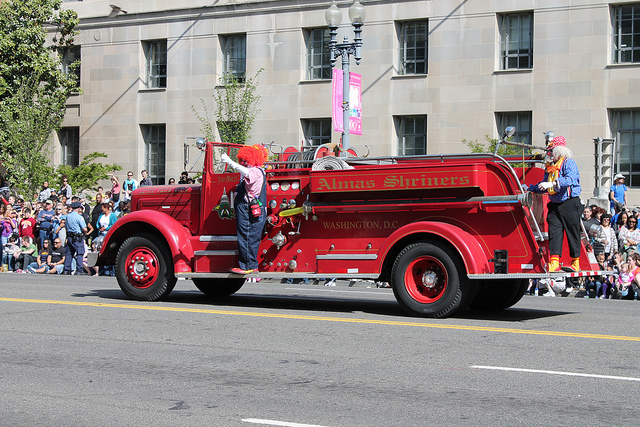<image>What is written on top of the truck? I don't know exactly what is written on top of the truck. It might be 'aluris shriners', 'almas shriners', 'shriners', or 'alias services'. What is written on top of the truck? I don't know what is written on top of the truck. It can be seen 'aluris shriners', 'almas shriners', 'shriners', 'ninas shriners', 'alias services' or 'not sure'. 